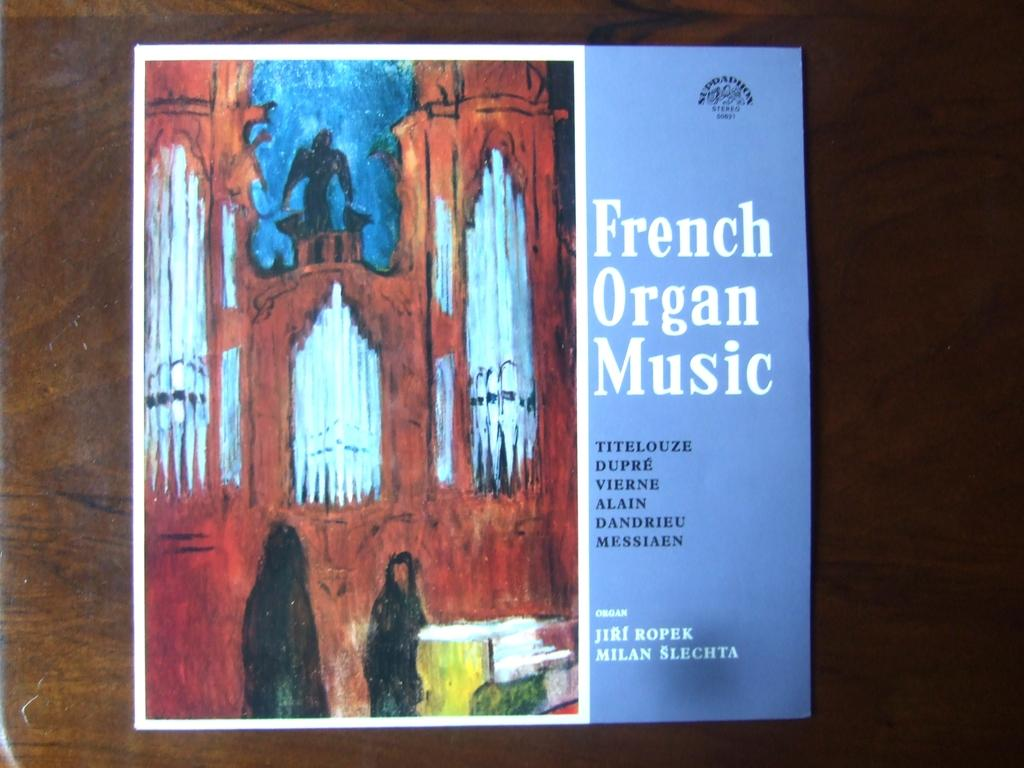Provide a one-sentence caption for the provided image. An album of French Organ Music with a blue color and picture of a cathedral. 